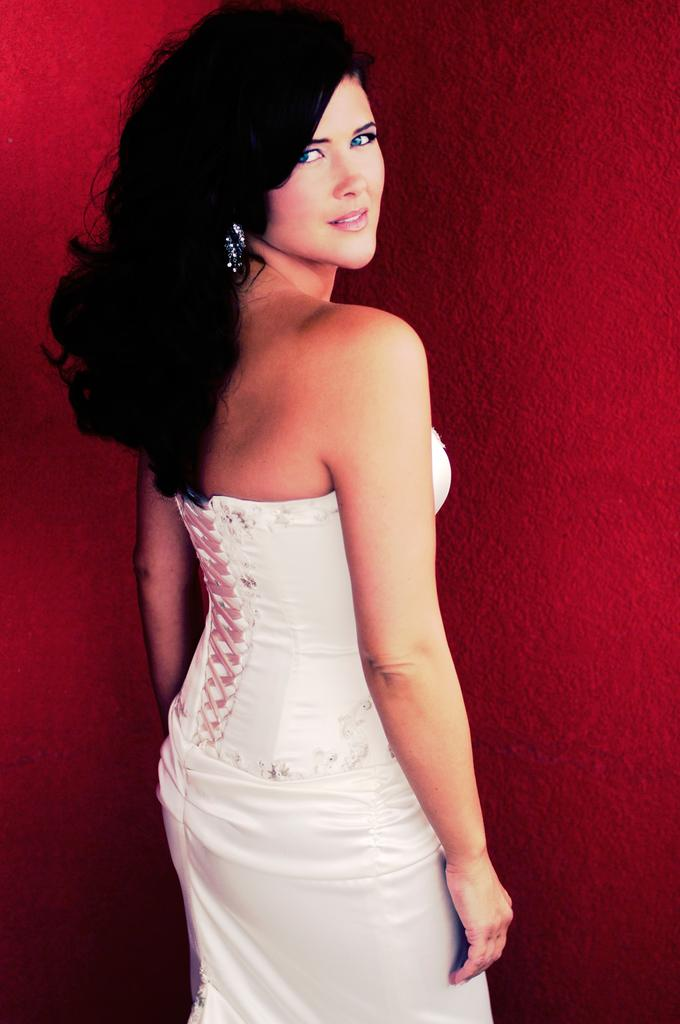Who is present in the image? There is a woman in the picture. What is the woman doing in the image? The woman is standing. What is the woman wearing in the image? The woman is wearing a white dress. What can be seen in the background of the image? There is a red color wall in the background of the image. What type of lizards can be seen participating in the protest in the image? There are no lizards or protest present in the image; it features a woman standing in front of a red wall. 